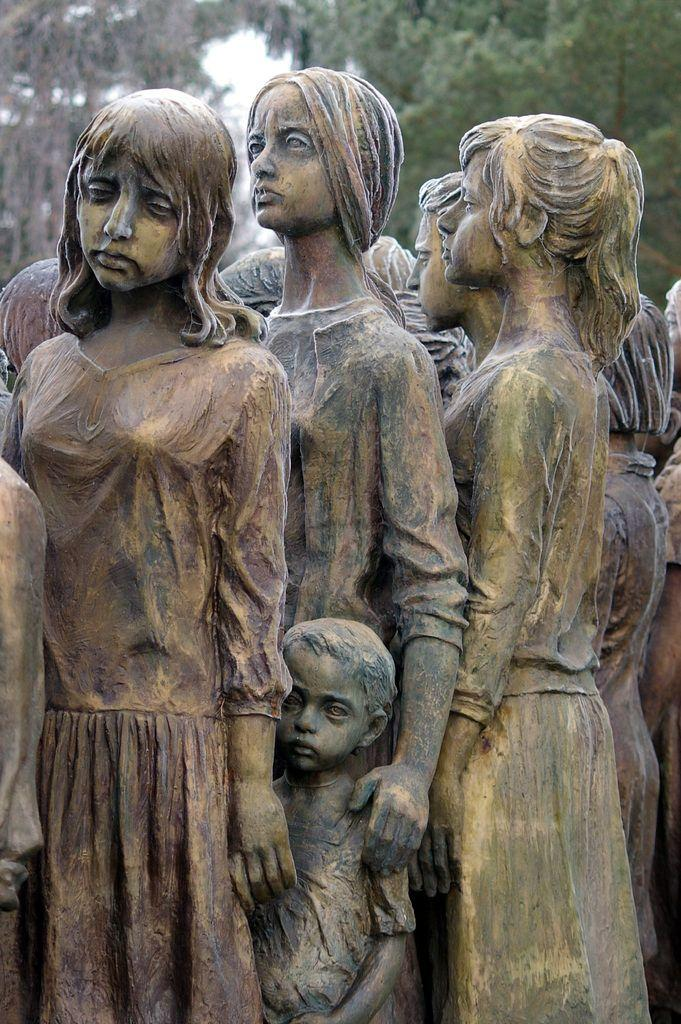What type of objects are depicted in the image? There are statues of people in the image. What can be seen in the background of the image? There are trees and the sky visible in the background of the image. What type of jewel is being fought over by the statues in the image? There are no jewels or fights depicted in the image; it features statues of people and a background with trees and the sky. 